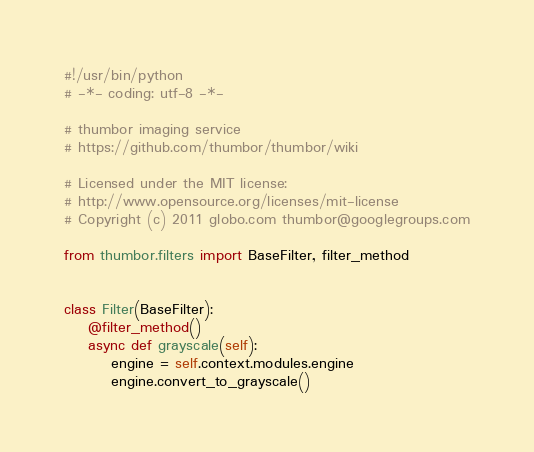Convert code to text. <code><loc_0><loc_0><loc_500><loc_500><_Python_>#!/usr/bin/python
# -*- coding: utf-8 -*-

# thumbor imaging service
# https://github.com/thumbor/thumbor/wiki

# Licensed under the MIT license:
# http://www.opensource.org/licenses/mit-license
# Copyright (c) 2011 globo.com thumbor@googlegroups.com

from thumbor.filters import BaseFilter, filter_method


class Filter(BaseFilter):
    @filter_method()
    async def grayscale(self):
        engine = self.context.modules.engine
        engine.convert_to_grayscale()
</code> 